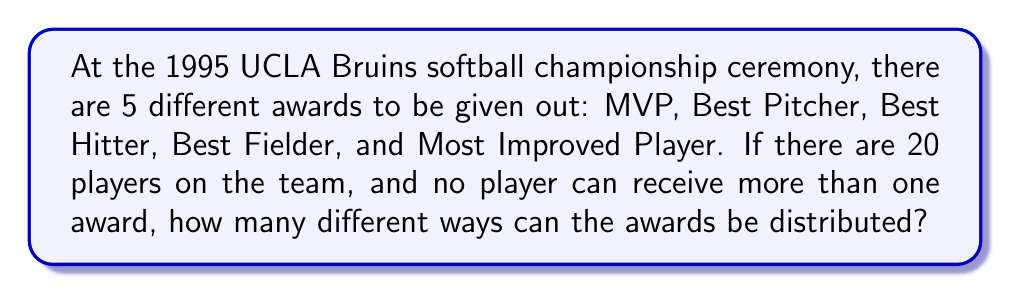What is the answer to this math problem? Let's approach this step-by-step:

1) This is a permutation problem because the order matters (each specific award is going to a specific player) and we're selecting players without replacement (no player can receive more than one award).

2) We can use the permutation formula:
   
   $P(n,r) = \frac{n!}{(n-r)!}$

   Where $n$ is the total number of items to choose from (in this case, 20 players), and $r$ is the number of items being chosen (in this case, 5 awards).

3) Plugging in our values:

   $P(20,5) = \frac{20!}{(20-5)!} = \frac{20!}{15!}$

4) Let's calculate this:

   $$\begin{align}
   \frac{20!}{15!} &= 20 \times 19 \times 18 \times 17 \times 16 \\
   &= 1,860,480
   \end{align}$$

5) Therefore, there are 1,860,480 different ways to distribute the 5 awards among the 20 players.
Answer: 1,860,480 